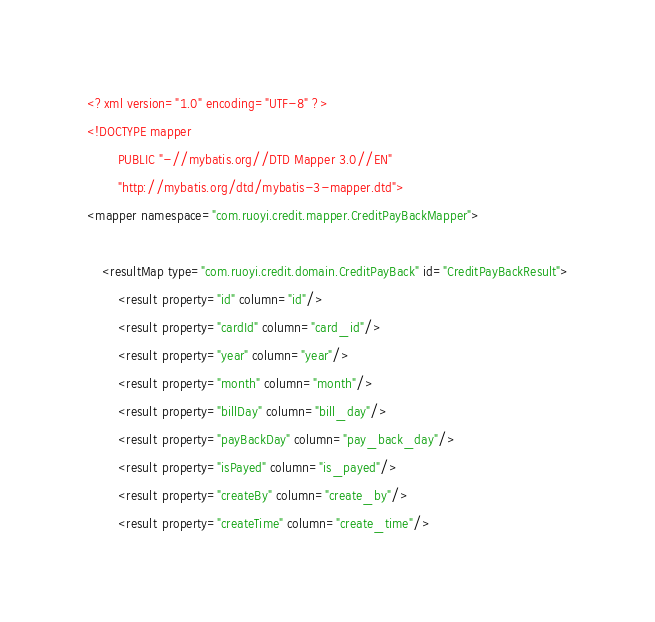Convert code to text. <code><loc_0><loc_0><loc_500><loc_500><_XML_><?xml version="1.0" encoding="UTF-8" ?>
<!DOCTYPE mapper
        PUBLIC "-//mybatis.org//DTD Mapper 3.0//EN"
        "http://mybatis.org/dtd/mybatis-3-mapper.dtd">
<mapper namespace="com.ruoyi.credit.mapper.CreditPayBackMapper">

    <resultMap type="com.ruoyi.credit.domain.CreditPayBack" id="CreditPayBackResult">
        <result property="id" column="id"/>
        <result property="cardId" column="card_id"/>
        <result property="year" column="year"/>
        <result property="month" column="month"/>
        <result property="billDay" column="bill_day"/>
        <result property="payBackDay" column="pay_back_day"/>
        <result property="isPayed" column="is_payed"/>
        <result property="createBy" column="create_by"/>
        <result property="createTime" column="create_time"/></code> 